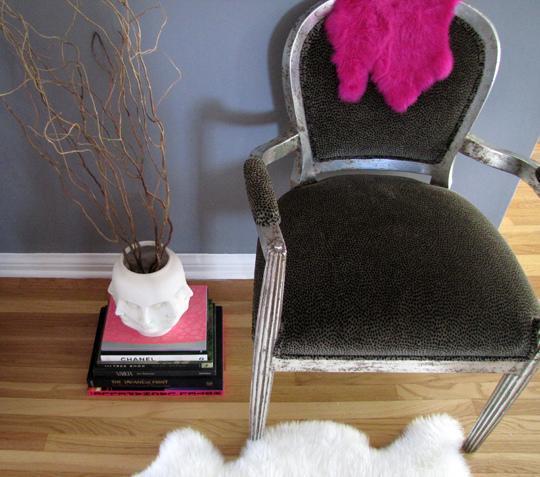How many chairs are there?
Give a very brief answer. 1. How many books are visible?
Give a very brief answer. 2. 